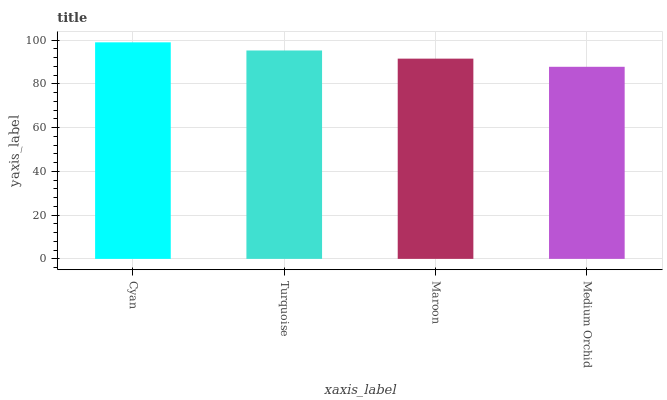Is Turquoise the minimum?
Answer yes or no. No. Is Turquoise the maximum?
Answer yes or no. No. Is Cyan greater than Turquoise?
Answer yes or no. Yes. Is Turquoise less than Cyan?
Answer yes or no. Yes. Is Turquoise greater than Cyan?
Answer yes or no. No. Is Cyan less than Turquoise?
Answer yes or no. No. Is Turquoise the high median?
Answer yes or no. Yes. Is Maroon the low median?
Answer yes or no. Yes. Is Maroon the high median?
Answer yes or no. No. Is Medium Orchid the low median?
Answer yes or no. No. 